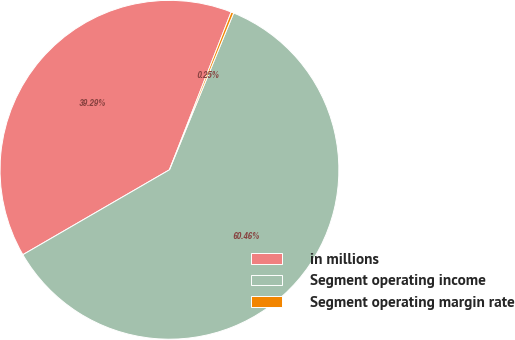Convert chart to OTSL. <chart><loc_0><loc_0><loc_500><loc_500><pie_chart><fcel>in millions<fcel>Segment operating income<fcel>Segment operating margin rate<nl><fcel>39.29%<fcel>60.46%<fcel>0.25%<nl></chart> 